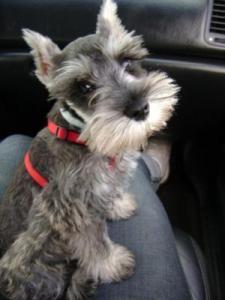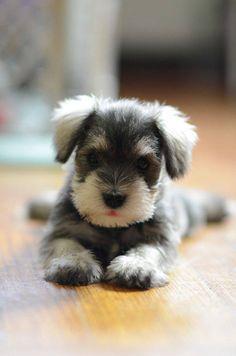The first image is the image on the left, the second image is the image on the right. Examine the images to the left and right. Is the description "An image shows a black-faced schnauzer with something blue by its front paws." accurate? Answer yes or no. No. 